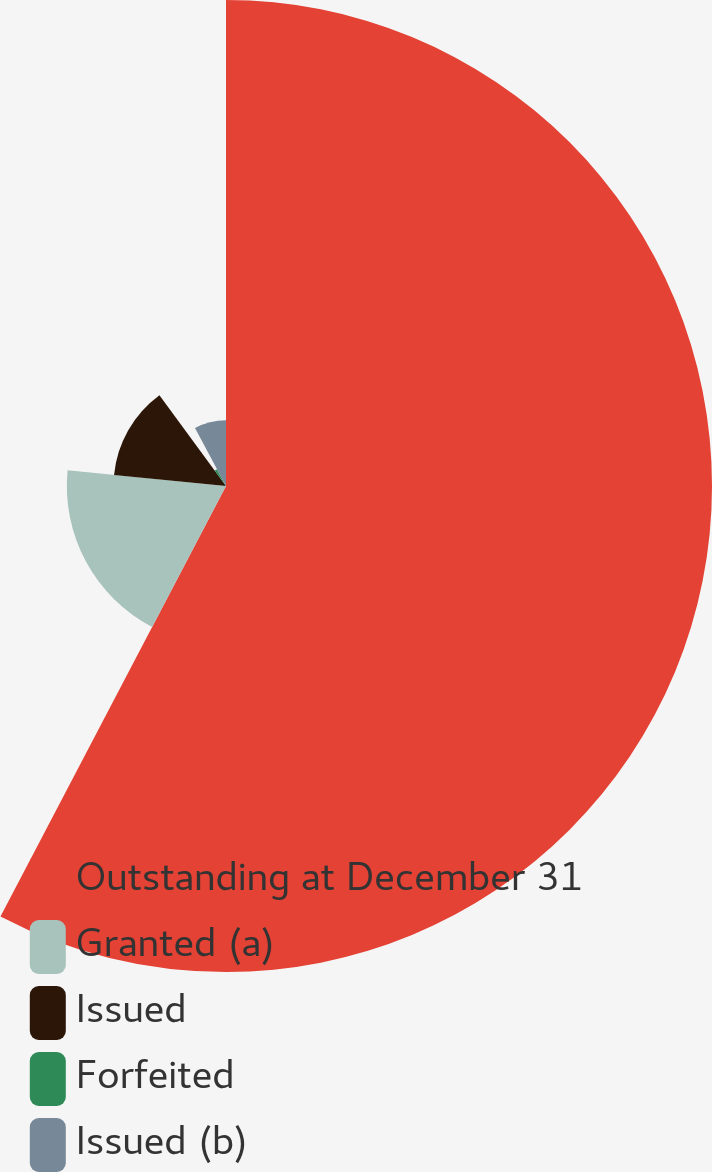Convert chart to OTSL. <chart><loc_0><loc_0><loc_500><loc_500><pie_chart><fcel>Outstanding at December 31<fcel>Granted (a)<fcel>Issued<fcel>Forfeited<fcel>Issued (b)<nl><fcel>57.68%<fcel>18.89%<fcel>13.35%<fcel>2.27%<fcel>7.81%<nl></chart> 